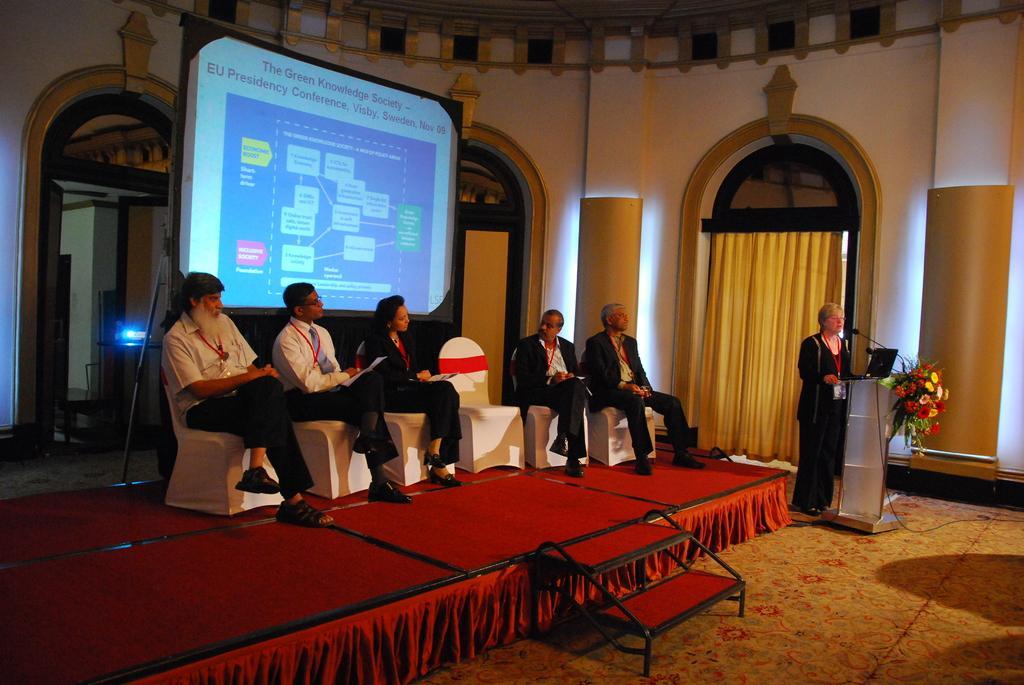How would you summarize this image in a sentence or two? In this image in the center there are some people who are sitting on chairs and one person is holding papers. On the right side there is one women who is standing, in front of her there is one podium. On the podium there is one laptop and mike it seems that she is talking and in the background there is a projector and some windows, doors and curtains. And at the bottom there is a carpet on the floor, on the top there is ceiling. 